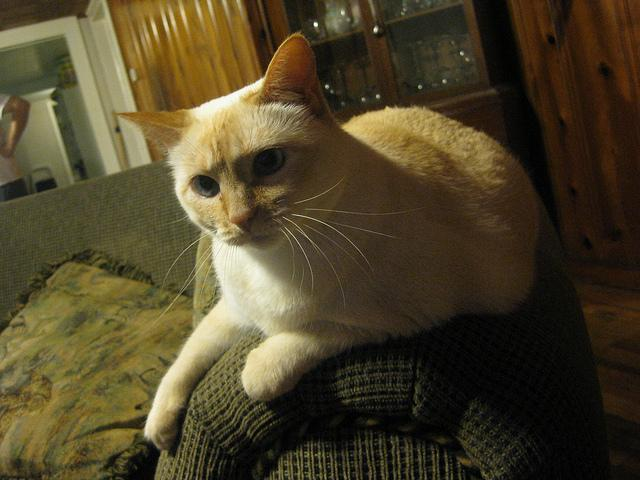What type of cat is this? Please explain your reasoning. short hair. That cat's fur does not stick out very much from its body. 